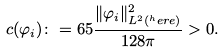Convert formula to latex. <formula><loc_0><loc_0><loc_500><loc_500>c ( \varphi _ { i } ) \colon = 6 5 \frac { \| \varphi _ { i } \| _ { L ^ { 2 } ( ^ { h } e r e ) } ^ { 2 } } { 1 2 8 \pi } > 0 .</formula> 